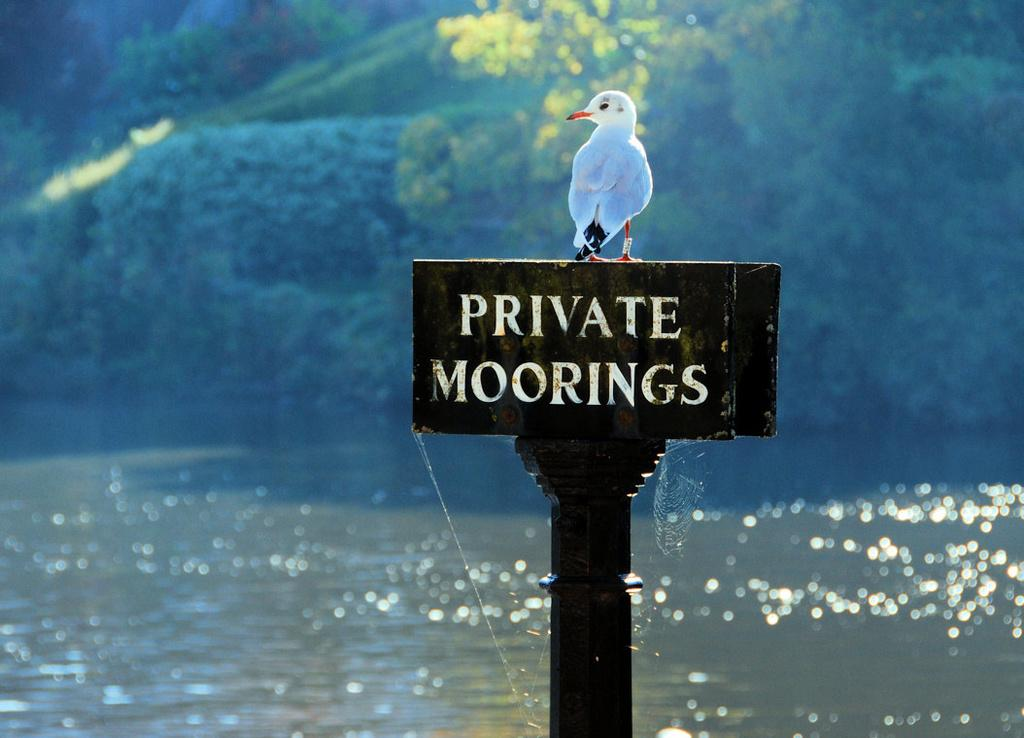What type of animal can be seen in the image? There is a bird in the image. Where is the bird located? The bird is on a black color pole. What can be seen in the background of the image? There is greenery and water visible in the background of the image. What committee is responsible for the bird's presence on the pole in the image? There is no committee mentioned or implied in the image, and the bird's presence on the pole is not related to any committee. 